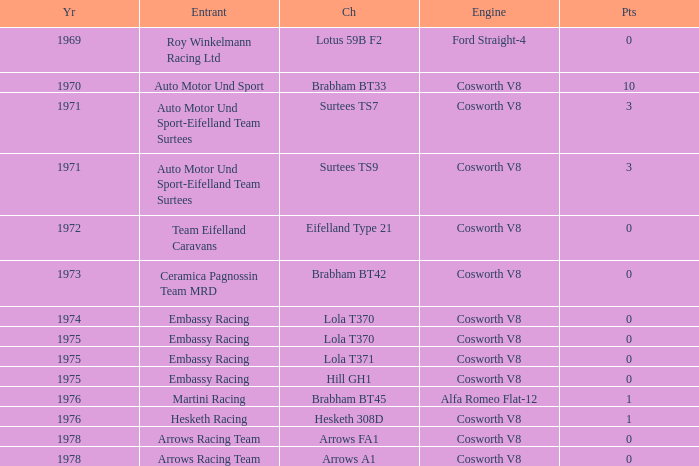Who was the entrant in 1971? Auto Motor Und Sport-Eifelland Team Surtees, Auto Motor Und Sport-Eifelland Team Surtees. 